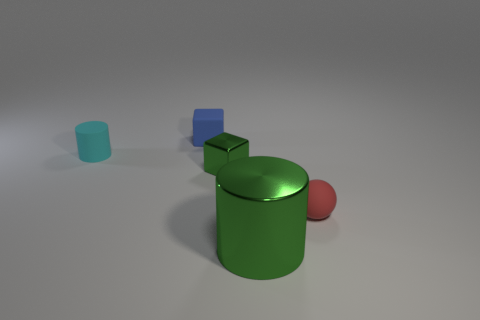Is the color of the small metal thing the same as the large object?
Your response must be concise. Yes. What material is the large cylinder that is the same color as the small shiny cube?
Make the answer very short. Metal. There is a green thing that is behind the cylinder that is to the right of the tiny cube that is in front of the tiny rubber block; what is its material?
Provide a succinct answer. Metal. Do the metal object behind the tiny red object and the object that is behind the tiny cyan object have the same shape?
Offer a very short reply. Yes. What number of other things are made of the same material as the tiny sphere?
Your answer should be very brief. 2. Do the small object that is in front of the small green object and the cylinder behind the big green shiny object have the same material?
Your response must be concise. Yes. There is a small object that is the same material as the big object; what is its shape?
Ensure brevity in your answer.  Cube. Are there any other things that are the same color as the matte block?
Offer a terse response. No. What number of metallic cylinders are there?
Give a very brief answer. 1. There is a object that is in front of the blue rubber cube and left of the green cube; what shape is it?
Ensure brevity in your answer.  Cylinder. 